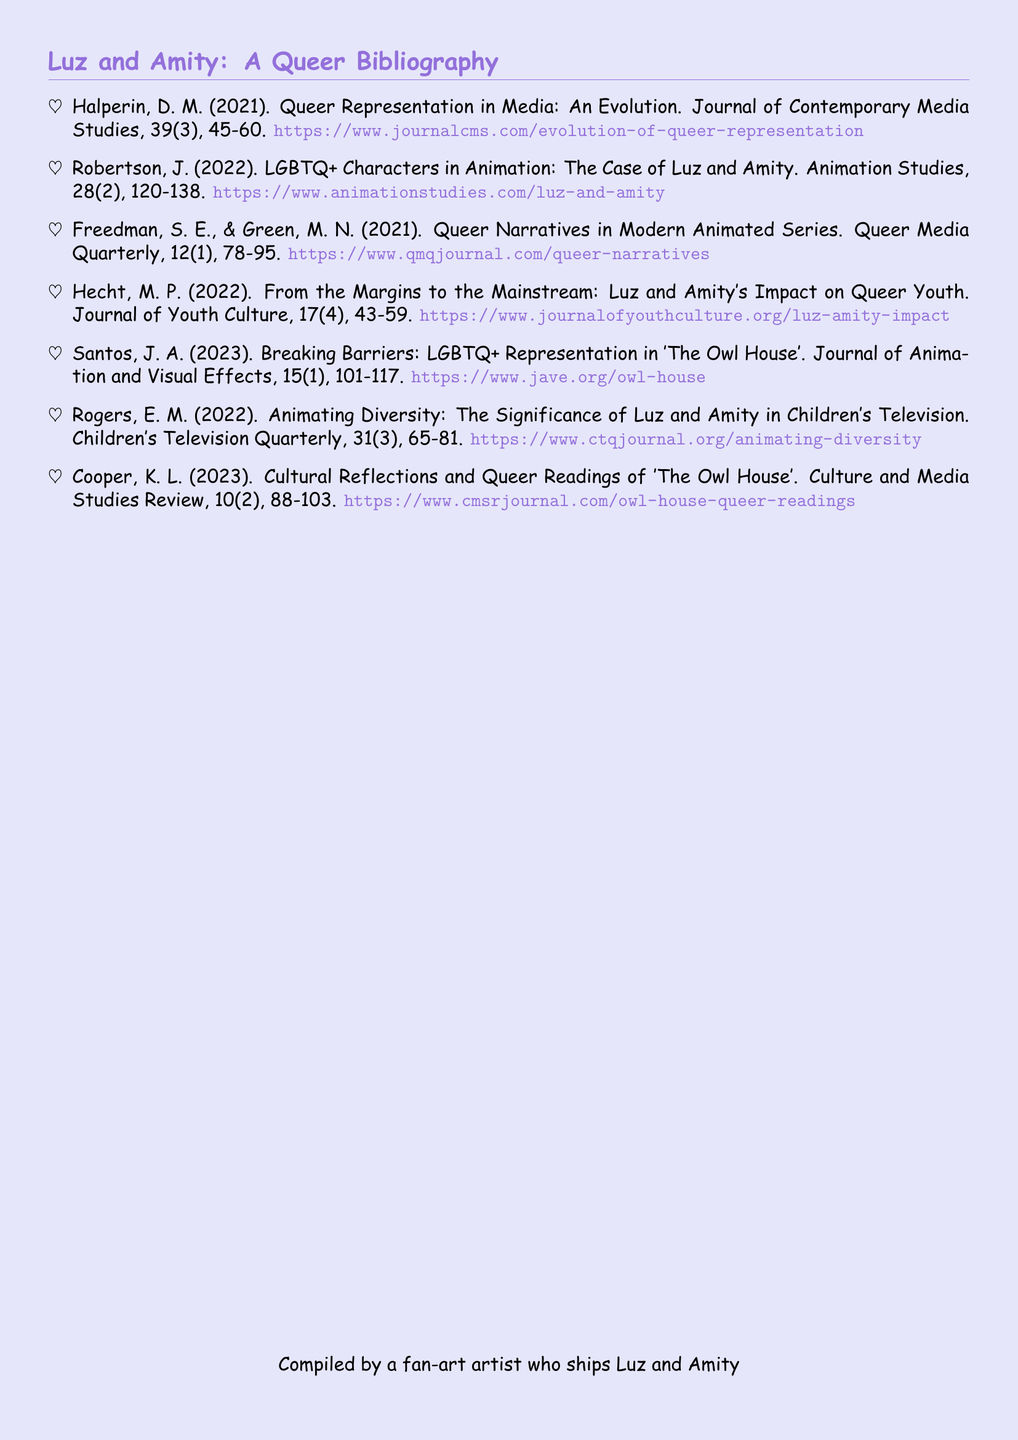What is the title of the first article in the bibliography? The title is the first piece of information listed in the citation of the article, which is "Queer Representation in Media: An Evolution."
Answer: Queer Representation in Media: An Evolution Who authored the article about LGBTQ+ Characters in Animation? The author is the person named first in the citation of that article, which is J. Robertson.
Answer: J. Robertson What volume and issue number is the article by Freedman and Green published in? The volume and issue are the details found in the citation; in this case, it is volume 12, issue 1.
Answer: 12(1) How many articles discuss the impact of Luz and Amity on queer youth? This is determined by counting the articles mentioning this topic in the bibliography. There is one such article.
Answer: 1 What year was the article "Breaking Barriers: LGBTQ+ Representation in 'The Owl House'" published? The year is found in the reference details of the article; it was published in 2023.
Answer: 2023 Which journal includes the article about cultural reflections on 'The Owl House'? The journal name can be found in the article's citation, which is "Culture and Media Studies Review."
Answer: Culture and Media Studies Review Which article has the URL ending with "owl-house"? The URL prefix can be identified through the citation, and the relevant article is "Breaking Barriers: LGBTQ+ Representation in 'The Owl House.'"
Answer: Breaking Barriers: LGBTQ+ Representation in 'The Owl House' What is the color theme used for the background of the document? The document's background color is specified in the code; the background is light purple.
Answer: light purple 